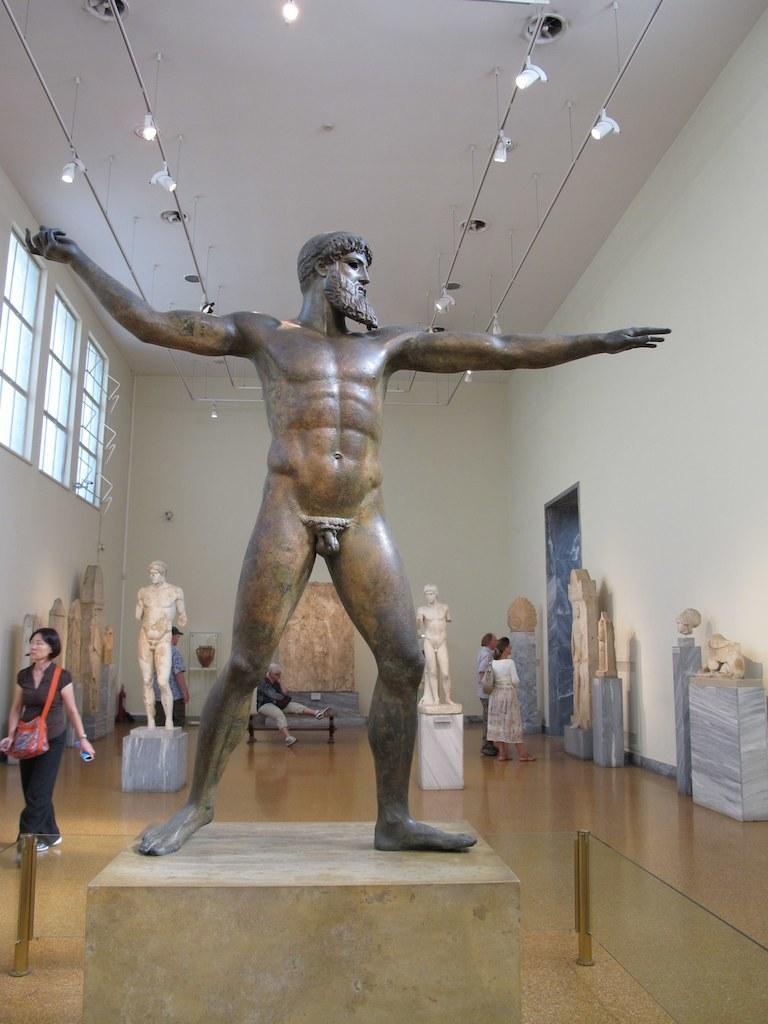Could you give a brief overview of what you see in this image? In the picture we can see a sculpture of a man standing on the stone in nude and behind it also we can see two men sculptures and beside it, we can two people are standing and a woman walking with a red colored bag and to the wall we can see a glass window and to the ceiling we can see some lights. 